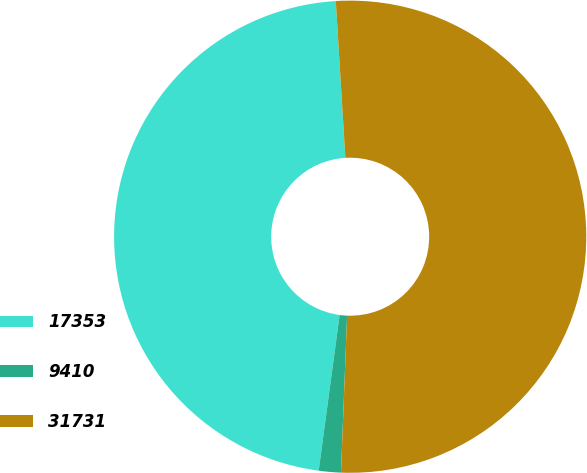<chart> <loc_0><loc_0><loc_500><loc_500><pie_chart><fcel>17353<fcel>9410<fcel>31731<nl><fcel>46.9%<fcel>1.51%<fcel>51.59%<nl></chart> 